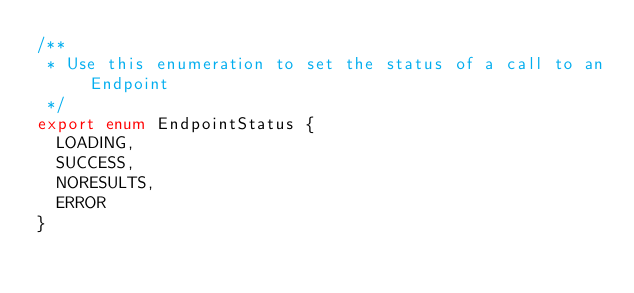<code> <loc_0><loc_0><loc_500><loc_500><_TypeScript_>/**
 * Use this enumeration to set the status of a call to an Endpoint
 */
export enum EndpointStatus {
  LOADING,
  SUCCESS,
  NORESULTS,
  ERROR
}
</code> 